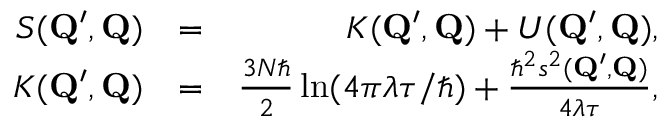<formula> <loc_0><loc_0><loc_500><loc_500>\begin{array} { r l r } { S ( Q ^ { \prime } , Q ) } & { = } & { K ( Q ^ { \prime } , Q ) + U ( Q ^ { \prime } , Q ) , } \\ { K ( Q ^ { \prime } , Q ) } & { = } & { \frac { 3 N } { 2 } \ln ( 4 \pi \lambda \tau / \hbar { ) } + \frac { \hbar { ^ } { 2 } s ^ { 2 } ( Q ^ { \prime } , Q ) } { 4 \lambda \tau } , } \end{array}</formula> 